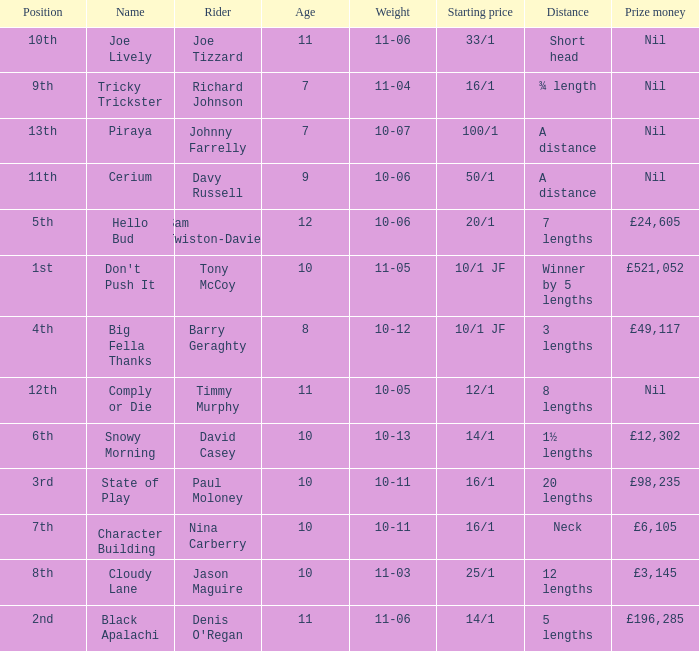 How much did Nina Carberry win?  £6,105. 